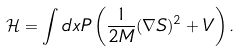<formula> <loc_0><loc_0><loc_500><loc_500>\mathcal { H } = \int d x P \left ( \frac { 1 } { 2 M } ( \nabla S ) ^ { 2 } + V \right ) .</formula> 